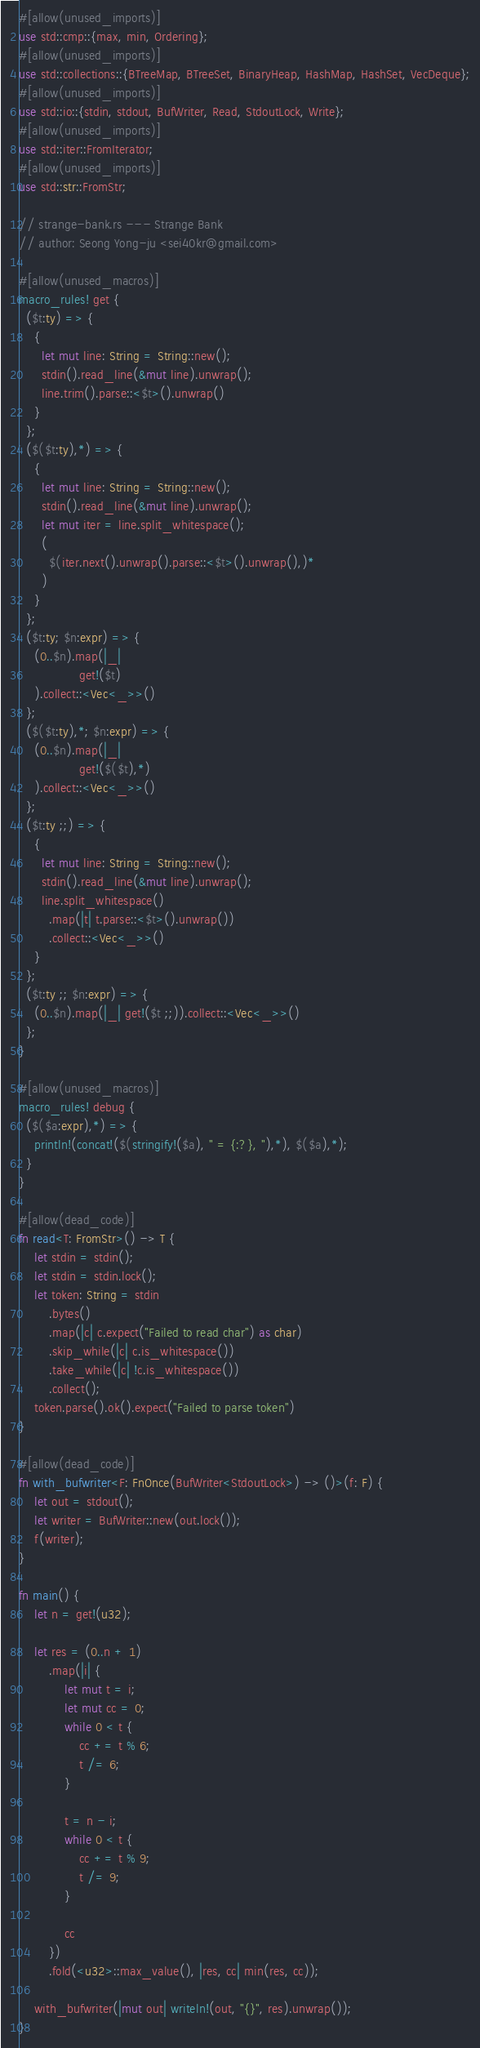<code> <loc_0><loc_0><loc_500><loc_500><_Rust_>#[allow(unused_imports)]
use std::cmp::{max, min, Ordering};
#[allow(unused_imports)]
use std::collections::{BTreeMap, BTreeSet, BinaryHeap, HashMap, HashSet, VecDeque};
#[allow(unused_imports)]
use std::io::{stdin, stdout, BufWriter, Read, StdoutLock, Write};
#[allow(unused_imports)]
use std::iter::FromIterator;
#[allow(unused_imports)]
use std::str::FromStr;

// strange-bank.rs --- Strange Bank
// author: Seong Yong-ju <sei40kr@gmail.com>

#[allow(unused_macros)]
macro_rules! get {
  ($t:ty) => {
    {
      let mut line: String = String::new();
      stdin().read_line(&mut line).unwrap();
      line.trim().parse::<$t>().unwrap()
    }
  };
  ($($t:ty),*) => {
    {
      let mut line: String = String::new();
      stdin().read_line(&mut line).unwrap();
      let mut iter = line.split_whitespace();
      (
        $(iter.next().unwrap().parse::<$t>().unwrap(),)*
      )
    }
  };
  ($t:ty; $n:expr) => {
    (0..$n).map(|_|
                get!($t)
    ).collect::<Vec<_>>()
  };
  ($($t:ty),*; $n:expr) => {
    (0..$n).map(|_|
                get!($($t),*)
    ).collect::<Vec<_>>()
  };
  ($t:ty ;;) => {
    {
      let mut line: String = String::new();
      stdin().read_line(&mut line).unwrap();
      line.split_whitespace()
        .map(|t| t.parse::<$t>().unwrap())
        .collect::<Vec<_>>()
    }
  };
  ($t:ty ;; $n:expr) => {
    (0..$n).map(|_| get!($t ;;)).collect::<Vec<_>>()
  };
}

#[allow(unused_macros)]
macro_rules! debug {
  ($($a:expr),*) => {
    println!(concat!($(stringify!($a), " = {:?}, "),*), $($a),*);
  }
}

#[allow(dead_code)]
fn read<T: FromStr>() -> T {
    let stdin = stdin();
    let stdin = stdin.lock();
    let token: String = stdin
        .bytes()
        .map(|c| c.expect("Failed to read char") as char)
        .skip_while(|c| c.is_whitespace())
        .take_while(|c| !c.is_whitespace())
        .collect();
    token.parse().ok().expect("Failed to parse token")
}

#[allow(dead_code)]
fn with_bufwriter<F: FnOnce(BufWriter<StdoutLock>) -> ()>(f: F) {
    let out = stdout();
    let writer = BufWriter::new(out.lock());
    f(writer);
}

fn main() {
    let n = get!(u32);

    let res = (0..n + 1)
        .map(|i| {
            let mut t = i;
            let mut cc = 0;
            while 0 < t {
                cc += t % 6;
                t /= 6;
            }

            t = n - i;
            while 0 < t {
                cc += t % 9;
                t /= 9;
            }

            cc
        })
        .fold(<u32>::max_value(), |res, cc| min(res, cc));

    with_bufwriter(|mut out| writeln!(out, "{}", res).unwrap());
}
</code> 